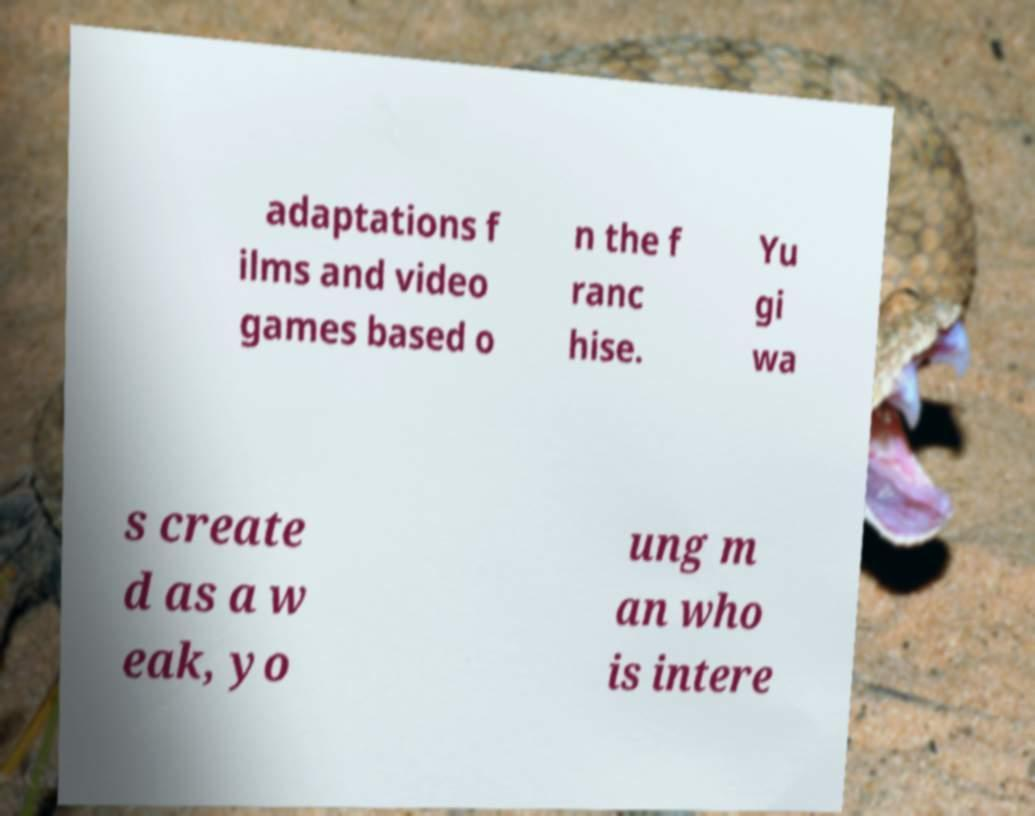Can you accurately transcribe the text from the provided image for me? adaptations f ilms and video games based o n the f ranc hise. Yu gi wa s create d as a w eak, yo ung m an who is intere 